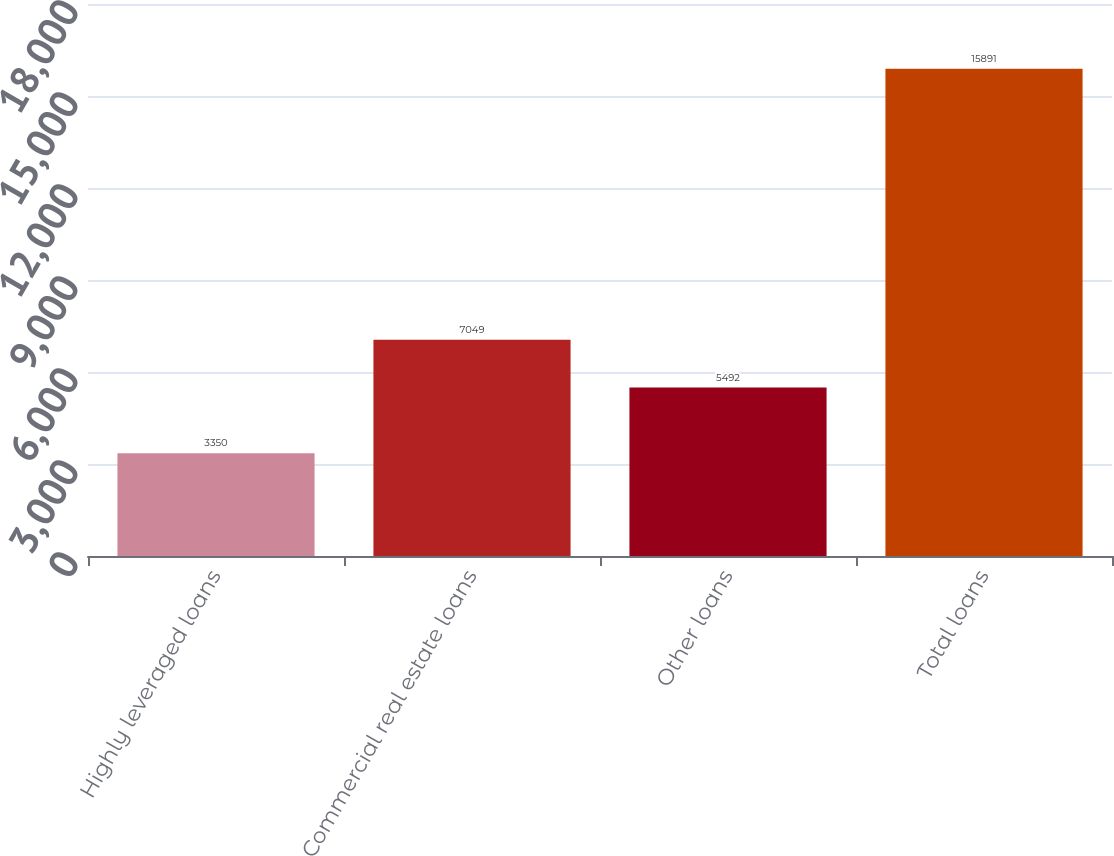Convert chart. <chart><loc_0><loc_0><loc_500><loc_500><bar_chart><fcel>Highly leveraged loans<fcel>Commercial real estate loans<fcel>Other loans<fcel>Total loans<nl><fcel>3350<fcel>7049<fcel>5492<fcel>15891<nl></chart> 